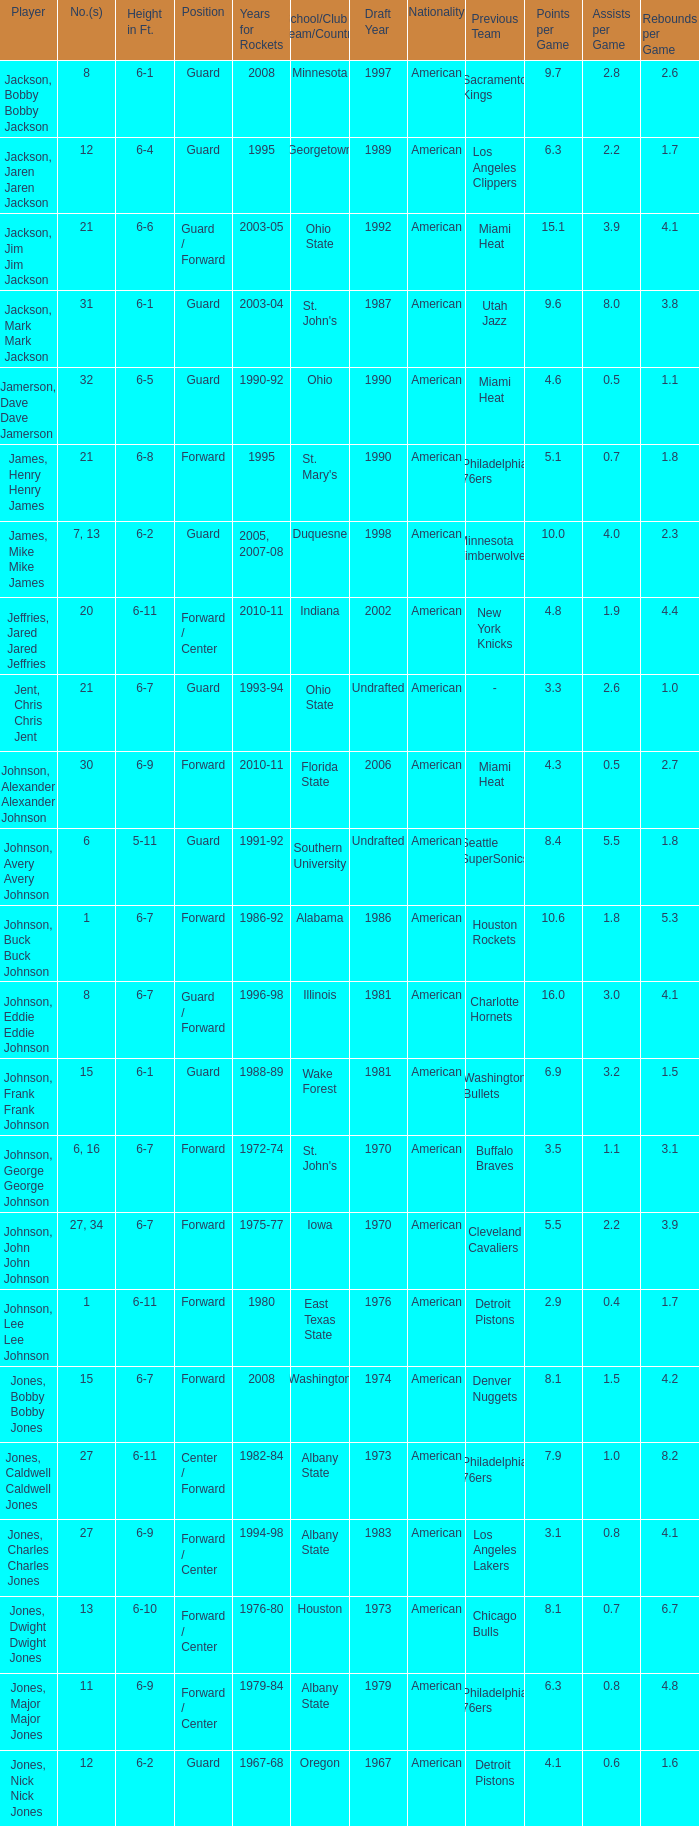How tall is the player jones, major major jones? 6-9. 